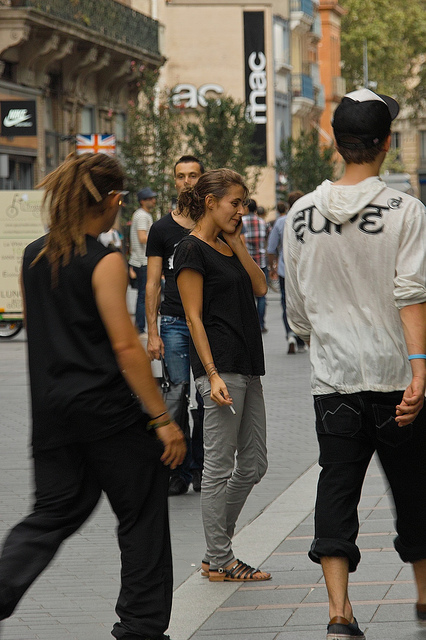<image>What type of hats are the men wearing? I am not sure what type of hats the men are wearing. It can be baseball caps or no hats at all. Where is the police car? The police car is not in the image. However, if it is, it might be on the road or street. What type of hats are the men wearing? I don't know what type of hats are the men wearing. It can be seen baseball caps or caps. Where is the police car? I don't know where the police car is. It might be on the road, on the left, or somewhere else. 